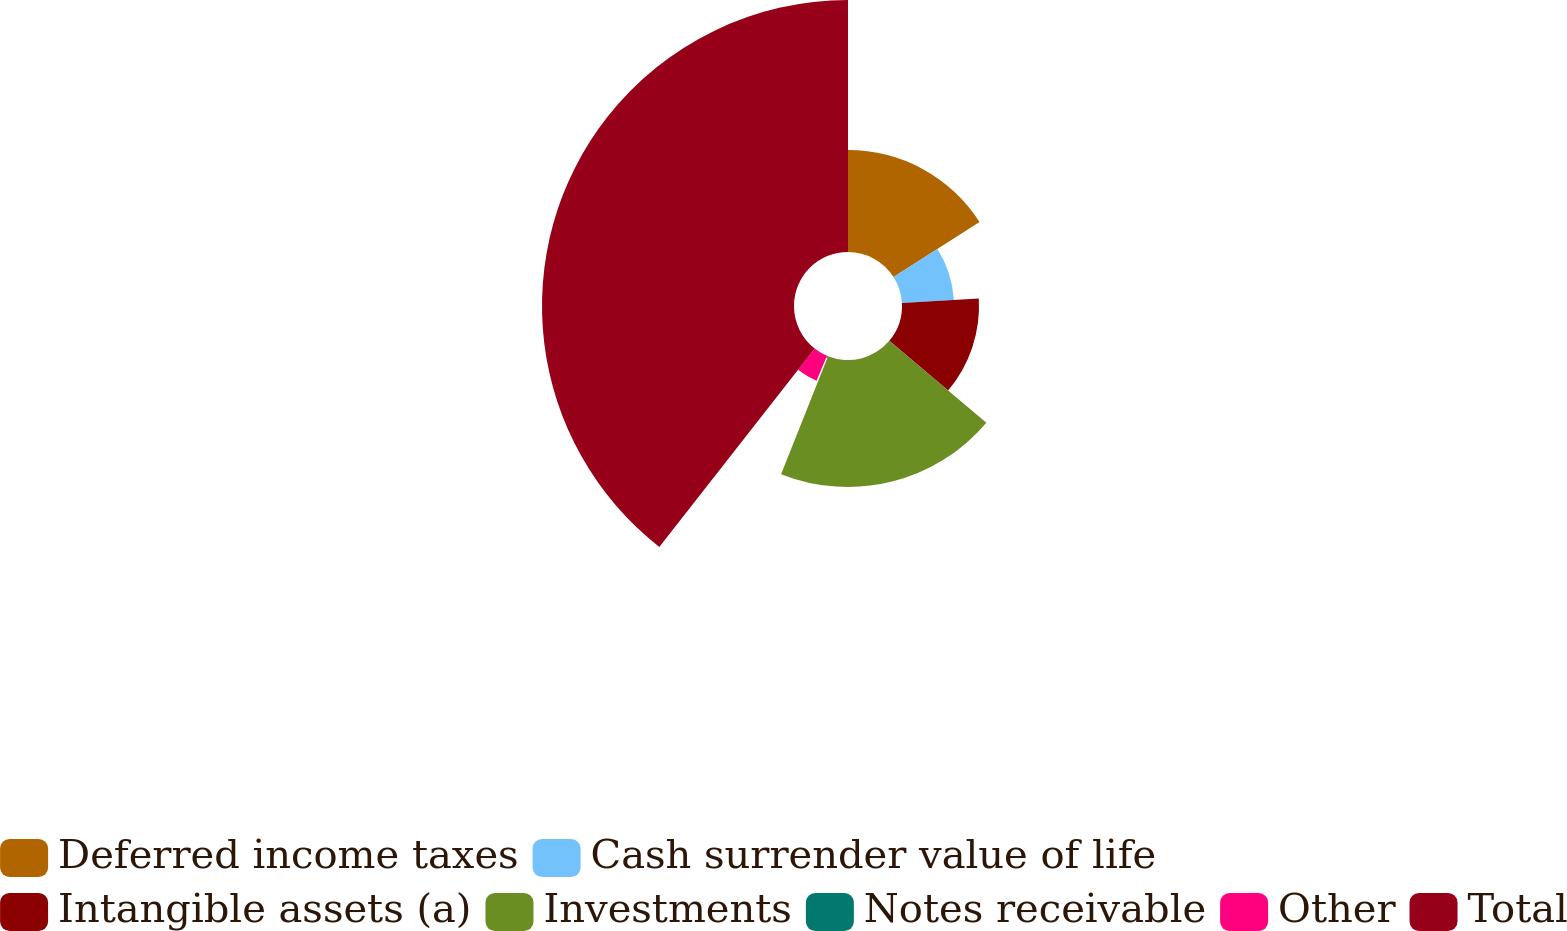Convert chart to OTSL. <chart><loc_0><loc_0><loc_500><loc_500><pie_chart><fcel>Deferred income taxes<fcel>Cash surrender value of life<fcel>Intangible assets (a)<fcel>Investments<fcel>Notes receivable<fcel>Other<fcel>Total<nl><fcel>15.96%<fcel>8.14%<fcel>12.05%<fcel>19.87%<fcel>0.32%<fcel>4.23%<fcel>39.42%<nl></chart> 